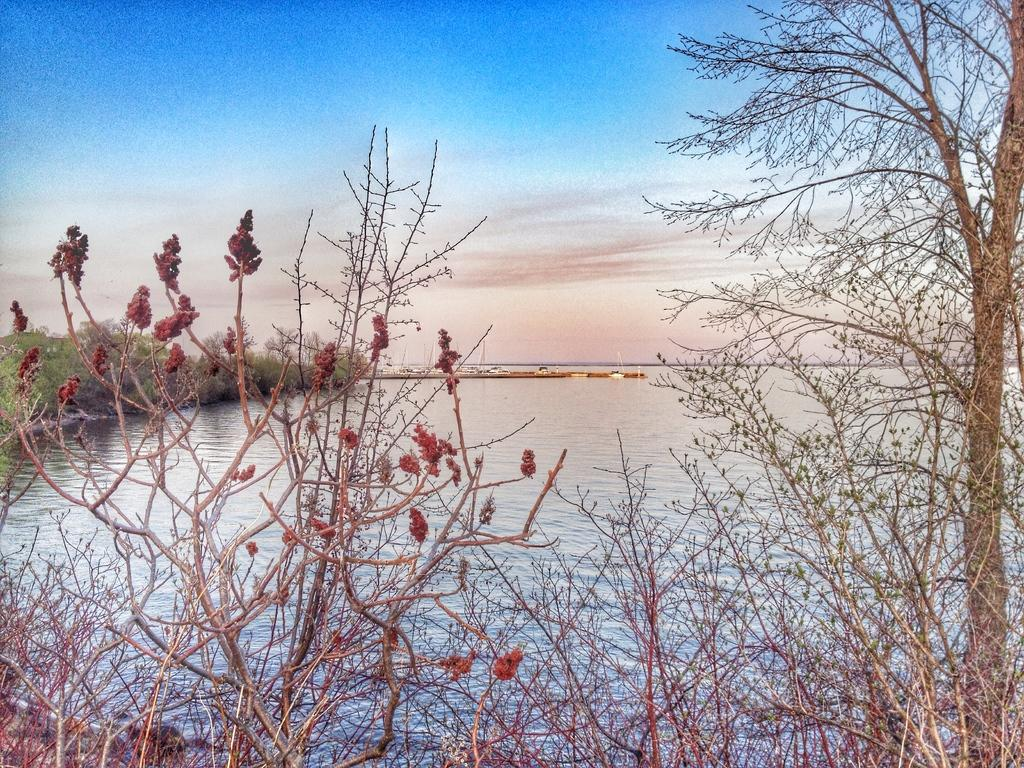What is the main feature in the center of the image? There is a river in the center of the image. What type of vegetation can be seen in the image? There are trees visible in the image. What can be seen in the background of the image? The sky is visible in the background of the image. How many pizzas are being cooked in the river in the image? There are no pizzas present in the image, and the river is not being used for cooking. 